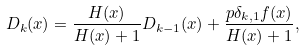Convert formula to latex. <formula><loc_0><loc_0><loc_500><loc_500>D _ { k } ( x ) = \frac { H ( x ) } { H ( x ) + 1 } D _ { k - 1 } ( x ) + \frac { p \delta _ { k , 1 } f ( x ) } { H ( x ) + 1 } ,</formula> 